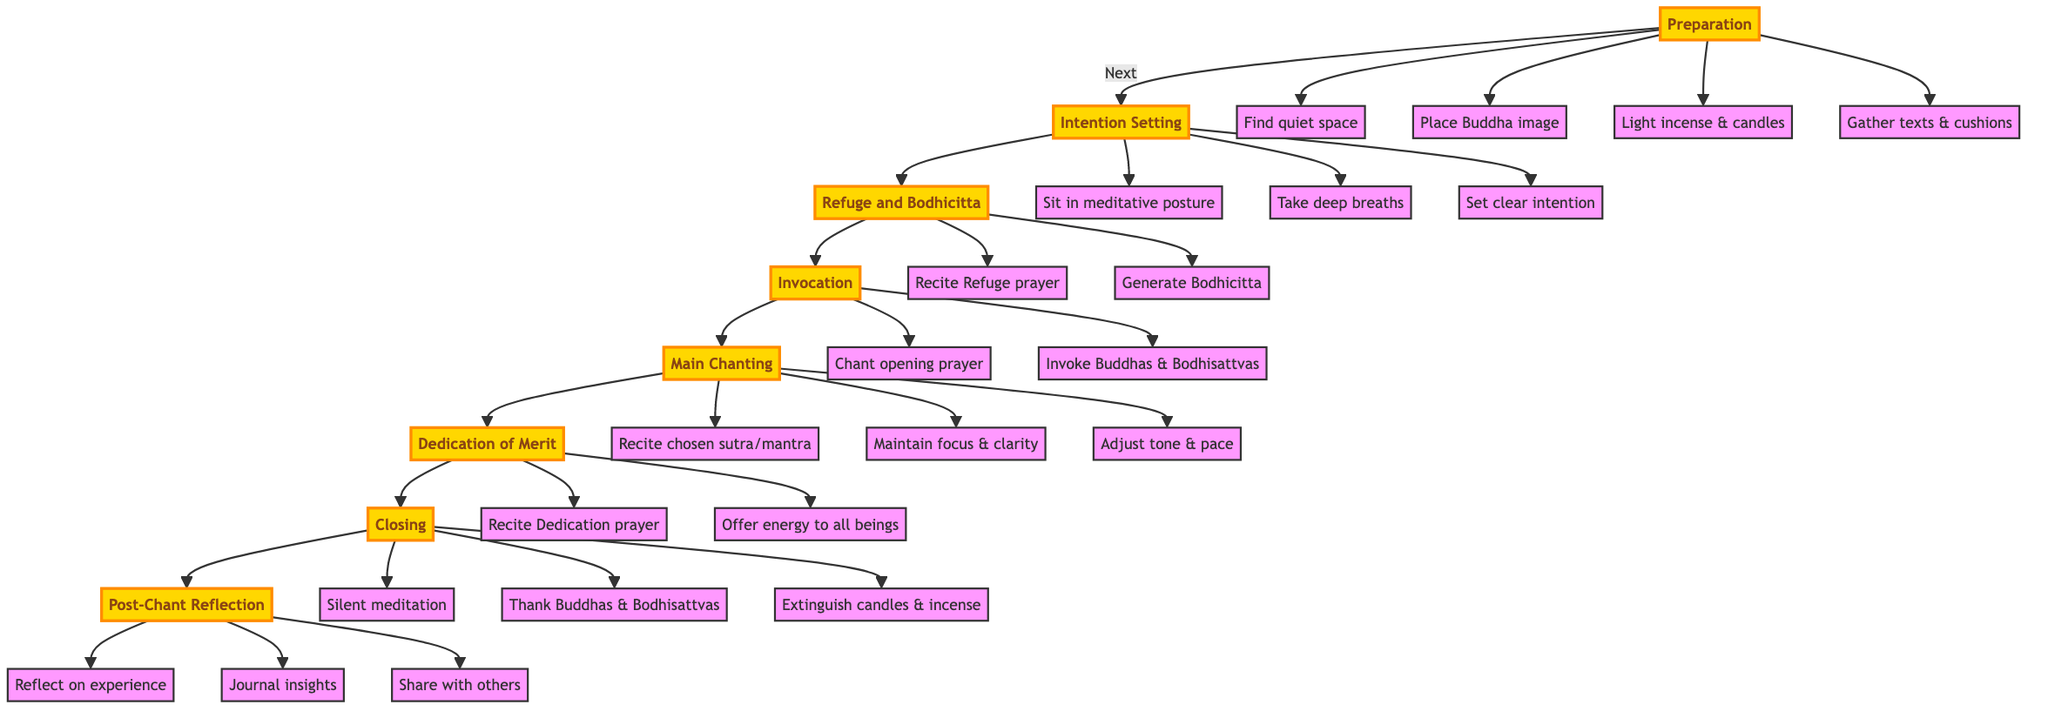What is the first step in the process? The first step is Preparation, indicated at the top of the flowchart.
Answer: Preparation How many main steps are there in the process? The flowchart shows eight main steps, from Preparation to Post-Chant Reflection.
Answer: Eight What activities are involved in the intention setting? Under the Intention Setting step, the activities include sitting in a meditative posture, taking deep breaths, and setting a clear intention.
Answer: Sit in meditative posture, take deep breaths, set clear intention Which step comes after the Invocation? Following the Invocation step, the next step is Main Chanting, as shown by the arrow connection in the flowchart.
Answer: Main Chanting What is the last activity in the Closing step? The last activity listed under the Closing step is to extinguish candles and incense.
Answer: Extinguish candles and incense Which two prayers are recited in the Refuge and Bodhicitta step? The two prayers recited in this step are the Refuge prayer and the Bodhicitta generation.
Answer: Recite Refuge prayer, Generate Bodhicitta In the Main Chanting process, what is maintained for clarity? The focus and clarity are maintained during the Main Chanting step, as specified in the activities.
Answer: Focus and clarity How does the process conclude after the Post-Chant Reflection? After the Post-Chant Reflection, the diagram does not show any further steps, indicating this is the final stage.
Answer: Final stage 